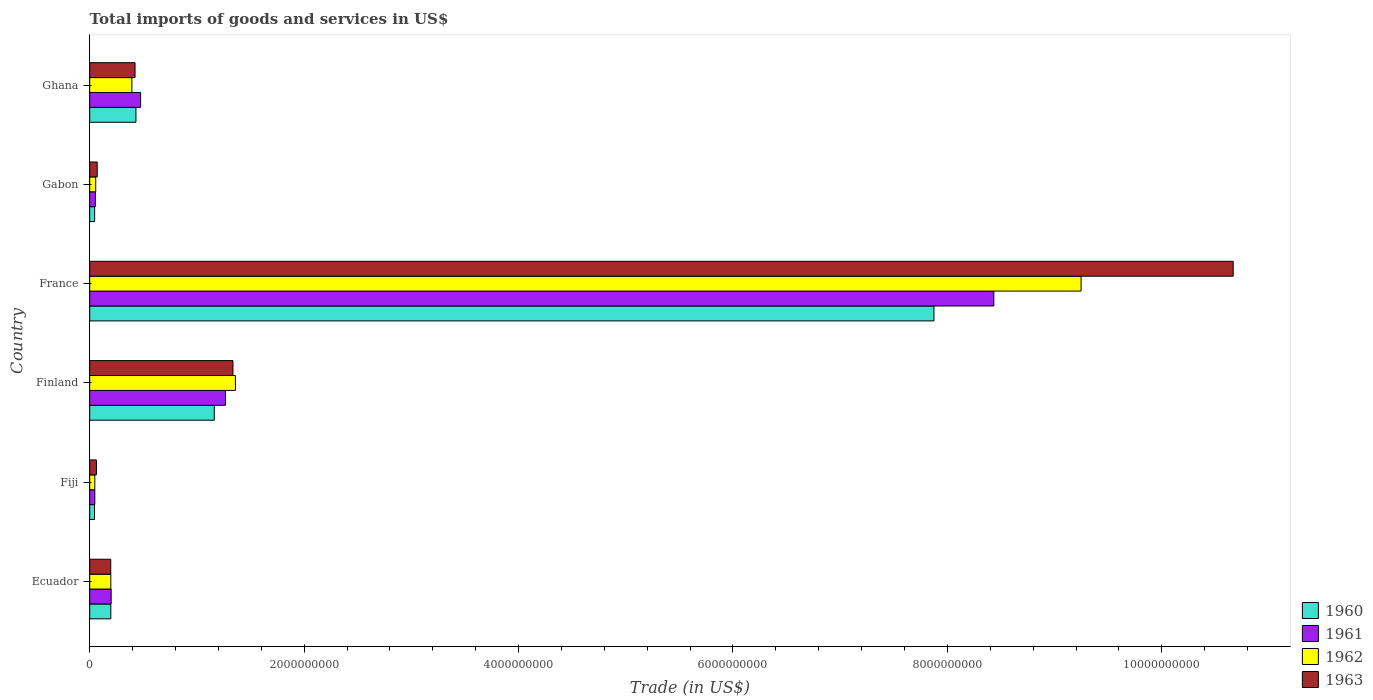How many different coloured bars are there?
Your answer should be compact. 4. Are the number of bars per tick equal to the number of legend labels?
Offer a very short reply. Yes. How many bars are there on the 5th tick from the top?
Keep it short and to the point. 4. What is the label of the 3rd group of bars from the top?
Offer a terse response. France. In how many cases, is the number of bars for a given country not equal to the number of legend labels?
Give a very brief answer. 0. What is the total imports of goods and services in 1960 in Ghana?
Provide a short and direct response. 4.31e+08. Across all countries, what is the maximum total imports of goods and services in 1962?
Your answer should be very brief. 9.25e+09. Across all countries, what is the minimum total imports of goods and services in 1961?
Your response must be concise. 4.77e+07. In which country was the total imports of goods and services in 1963 minimum?
Your answer should be very brief. Fiji. What is the total total imports of goods and services in 1963 in the graph?
Give a very brief answer. 1.28e+1. What is the difference between the total imports of goods and services in 1960 in Fiji and that in Ghana?
Make the answer very short. -3.87e+08. What is the difference between the total imports of goods and services in 1962 in Ghana and the total imports of goods and services in 1963 in Fiji?
Offer a terse response. 3.31e+08. What is the average total imports of goods and services in 1961 per country?
Your answer should be compact. 1.75e+09. What is the difference between the total imports of goods and services in 1960 and total imports of goods and services in 1962 in Ghana?
Your answer should be very brief. 3.78e+07. In how many countries, is the total imports of goods and services in 1962 greater than 3200000000 US$?
Ensure brevity in your answer.  1. What is the ratio of the total imports of goods and services in 1962 in Fiji to that in Gabon?
Offer a very short reply. 0.85. What is the difference between the highest and the second highest total imports of goods and services in 1963?
Make the answer very short. 9.33e+09. What is the difference between the highest and the lowest total imports of goods and services in 1962?
Give a very brief answer. 9.20e+09. In how many countries, is the total imports of goods and services in 1960 greater than the average total imports of goods and services in 1960 taken over all countries?
Provide a succinct answer. 1. Is it the case that in every country, the sum of the total imports of goods and services in 1963 and total imports of goods and services in 1960 is greater than the sum of total imports of goods and services in 1961 and total imports of goods and services in 1962?
Keep it short and to the point. No. What does the 4th bar from the bottom in Ecuador represents?
Your response must be concise. 1963. Is it the case that in every country, the sum of the total imports of goods and services in 1962 and total imports of goods and services in 1961 is greater than the total imports of goods and services in 1963?
Keep it short and to the point. Yes. How many bars are there?
Offer a terse response. 24. Are the values on the major ticks of X-axis written in scientific E-notation?
Keep it short and to the point. No. Does the graph contain any zero values?
Offer a very short reply. No. Where does the legend appear in the graph?
Provide a succinct answer. Bottom right. What is the title of the graph?
Your answer should be very brief. Total imports of goods and services in US$. What is the label or title of the X-axis?
Ensure brevity in your answer.  Trade (in US$). What is the label or title of the Y-axis?
Keep it short and to the point. Country. What is the Trade (in US$) of 1960 in Ecuador?
Make the answer very short. 1.97e+08. What is the Trade (in US$) in 1961 in Ecuador?
Offer a very short reply. 2.00e+08. What is the Trade (in US$) of 1962 in Ecuador?
Ensure brevity in your answer.  1.97e+08. What is the Trade (in US$) of 1963 in Ecuador?
Provide a succinct answer. 1.96e+08. What is the Trade (in US$) of 1960 in Fiji?
Offer a terse response. 4.48e+07. What is the Trade (in US$) of 1961 in Fiji?
Your answer should be very brief. 4.77e+07. What is the Trade (in US$) of 1962 in Fiji?
Your answer should be compact. 4.77e+07. What is the Trade (in US$) of 1963 in Fiji?
Keep it short and to the point. 6.30e+07. What is the Trade (in US$) of 1960 in Finland?
Your answer should be very brief. 1.16e+09. What is the Trade (in US$) of 1961 in Finland?
Offer a very short reply. 1.27e+09. What is the Trade (in US$) of 1962 in Finland?
Ensure brevity in your answer.  1.36e+09. What is the Trade (in US$) of 1963 in Finland?
Your answer should be very brief. 1.34e+09. What is the Trade (in US$) of 1960 in France?
Your response must be concise. 7.87e+09. What is the Trade (in US$) of 1961 in France?
Offer a very short reply. 8.43e+09. What is the Trade (in US$) in 1962 in France?
Your answer should be compact. 9.25e+09. What is the Trade (in US$) of 1963 in France?
Offer a terse response. 1.07e+1. What is the Trade (in US$) of 1960 in Gabon?
Offer a terse response. 4.62e+07. What is the Trade (in US$) in 1961 in Gabon?
Make the answer very short. 5.31e+07. What is the Trade (in US$) in 1962 in Gabon?
Keep it short and to the point. 5.62e+07. What is the Trade (in US$) in 1963 in Gabon?
Offer a very short reply. 7.01e+07. What is the Trade (in US$) of 1960 in Ghana?
Offer a very short reply. 4.31e+08. What is the Trade (in US$) in 1961 in Ghana?
Give a very brief answer. 4.75e+08. What is the Trade (in US$) in 1962 in Ghana?
Your response must be concise. 3.94e+08. What is the Trade (in US$) in 1963 in Ghana?
Make the answer very short. 4.23e+08. Across all countries, what is the maximum Trade (in US$) in 1960?
Give a very brief answer. 7.87e+09. Across all countries, what is the maximum Trade (in US$) of 1961?
Make the answer very short. 8.43e+09. Across all countries, what is the maximum Trade (in US$) of 1962?
Provide a short and direct response. 9.25e+09. Across all countries, what is the maximum Trade (in US$) in 1963?
Your answer should be very brief. 1.07e+1. Across all countries, what is the minimum Trade (in US$) of 1960?
Keep it short and to the point. 4.48e+07. Across all countries, what is the minimum Trade (in US$) in 1961?
Your response must be concise. 4.77e+07. Across all countries, what is the minimum Trade (in US$) in 1962?
Offer a very short reply. 4.77e+07. Across all countries, what is the minimum Trade (in US$) in 1963?
Give a very brief answer. 6.30e+07. What is the total Trade (in US$) of 1960 in the graph?
Offer a terse response. 9.76e+09. What is the total Trade (in US$) in 1961 in the graph?
Make the answer very short. 1.05e+1. What is the total Trade (in US$) in 1962 in the graph?
Your answer should be compact. 1.13e+1. What is the total Trade (in US$) of 1963 in the graph?
Give a very brief answer. 1.28e+1. What is the difference between the Trade (in US$) in 1960 in Ecuador and that in Fiji?
Your answer should be very brief. 1.52e+08. What is the difference between the Trade (in US$) in 1961 in Ecuador and that in Fiji?
Your answer should be compact. 1.53e+08. What is the difference between the Trade (in US$) of 1962 in Ecuador and that in Fiji?
Give a very brief answer. 1.49e+08. What is the difference between the Trade (in US$) of 1963 in Ecuador and that in Fiji?
Your response must be concise. 1.33e+08. What is the difference between the Trade (in US$) of 1960 in Ecuador and that in Finland?
Offer a very short reply. -9.65e+08. What is the difference between the Trade (in US$) in 1961 in Ecuador and that in Finland?
Keep it short and to the point. -1.07e+09. What is the difference between the Trade (in US$) in 1962 in Ecuador and that in Finland?
Your answer should be compact. -1.16e+09. What is the difference between the Trade (in US$) of 1963 in Ecuador and that in Finland?
Give a very brief answer. -1.14e+09. What is the difference between the Trade (in US$) in 1960 in Ecuador and that in France?
Your answer should be compact. -7.68e+09. What is the difference between the Trade (in US$) of 1961 in Ecuador and that in France?
Offer a terse response. -8.23e+09. What is the difference between the Trade (in US$) of 1962 in Ecuador and that in France?
Provide a succinct answer. -9.05e+09. What is the difference between the Trade (in US$) of 1963 in Ecuador and that in France?
Your answer should be very brief. -1.05e+1. What is the difference between the Trade (in US$) in 1960 in Ecuador and that in Gabon?
Your answer should be compact. 1.51e+08. What is the difference between the Trade (in US$) of 1961 in Ecuador and that in Gabon?
Your response must be concise. 1.47e+08. What is the difference between the Trade (in US$) in 1962 in Ecuador and that in Gabon?
Your response must be concise. 1.41e+08. What is the difference between the Trade (in US$) of 1963 in Ecuador and that in Gabon?
Ensure brevity in your answer.  1.26e+08. What is the difference between the Trade (in US$) in 1960 in Ecuador and that in Ghana?
Give a very brief answer. -2.35e+08. What is the difference between the Trade (in US$) of 1961 in Ecuador and that in Ghana?
Your answer should be very brief. -2.75e+08. What is the difference between the Trade (in US$) in 1962 in Ecuador and that in Ghana?
Keep it short and to the point. -1.97e+08. What is the difference between the Trade (in US$) in 1963 in Ecuador and that in Ghana?
Give a very brief answer. -2.27e+08. What is the difference between the Trade (in US$) of 1960 in Fiji and that in Finland?
Offer a terse response. -1.12e+09. What is the difference between the Trade (in US$) in 1961 in Fiji and that in Finland?
Offer a terse response. -1.22e+09. What is the difference between the Trade (in US$) in 1962 in Fiji and that in Finland?
Provide a short and direct response. -1.31e+09. What is the difference between the Trade (in US$) in 1963 in Fiji and that in Finland?
Ensure brevity in your answer.  -1.27e+09. What is the difference between the Trade (in US$) of 1960 in Fiji and that in France?
Make the answer very short. -7.83e+09. What is the difference between the Trade (in US$) of 1961 in Fiji and that in France?
Keep it short and to the point. -8.39e+09. What is the difference between the Trade (in US$) in 1962 in Fiji and that in France?
Provide a short and direct response. -9.20e+09. What is the difference between the Trade (in US$) of 1963 in Fiji and that in France?
Your response must be concise. -1.06e+1. What is the difference between the Trade (in US$) in 1960 in Fiji and that in Gabon?
Offer a very short reply. -1.32e+06. What is the difference between the Trade (in US$) in 1961 in Fiji and that in Gabon?
Keep it short and to the point. -5.35e+06. What is the difference between the Trade (in US$) in 1962 in Fiji and that in Gabon?
Make the answer very short. -8.51e+06. What is the difference between the Trade (in US$) of 1963 in Fiji and that in Gabon?
Your answer should be very brief. -7.16e+06. What is the difference between the Trade (in US$) in 1960 in Fiji and that in Ghana?
Provide a short and direct response. -3.87e+08. What is the difference between the Trade (in US$) in 1961 in Fiji and that in Ghana?
Provide a short and direct response. -4.27e+08. What is the difference between the Trade (in US$) in 1962 in Fiji and that in Ghana?
Your answer should be very brief. -3.46e+08. What is the difference between the Trade (in US$) of 1963 in Fiji and that in Ghana?
Ensure brevity in your answer.  -3.60e+08. What is the difference between the Trade (in US$) of 1960 in Finland and that in France?
Ensure brevity in your answer.  -6.71e+09. What is the difference between the Trade (in US$) in 1961 in Finland and that in France?
Provide a succinct answer. -7.17e+09. What is the difference between the Trade (in US$) of 1962 in Finland and that in France?
Make the answer very short. -7.89e+09. What is the difference between the Trade (in US$) of 1963 in Finland and that in France?
Offer a terse response. -9.33e+09. What is the difference between the Trade (in US$) of 1960 in Finland and that in Gabon?
Your answer should be very brief. 1.12e+09. What is the difference between the Trade (in US$) in 1961 in Finland and that in Gabon?
Make the answer very short. 1.21e+09. What is the difference between the Trade (in US$) in 1962 in Finland and that in Gabon?
Offer a terse response. 1.30e+09. What is the difference between the Trade (in US$) of 1963 in Finland and that in Gabon?
Make the answer very short. 1.27e+09. What is the difference between the Trade (in US$) in 1960 in Finland and that in Ghana?
Offer a very short reply. 7.30e+08. What is the difference between the Trade (in US$) of 1961 in Finland and that in Ghana?
Offer a terse response. 7.91e+08. What is the difference between the Trade (in US$) of 1962 in Finland and that in Ghana?
Keep it short and to the point. 9.66e+08. What is the difference between the Trade (in US$) of 1963 in Finland and that in Ghana?
Your response must be concise. 9.13e+08. What is the difference between the Trade (in US$) in 1960 in France and that in Gabon?
Ensure brevity in your answer.  7.83e+09. What is the difference between the Trade (in US$) in 1961 in France and that in Gabon?
Your answer should be very brief. 8.38e+09. What is the difference between the Trade (in US$) in 1962 in France and that in Gabon?
Provide a short and direct response. 9.19e+09. What is the difference between the Trade (in US$) of 1963 in France and that in Gabon?
Offer a very short reply. 1.06e+1. What is the difference between the Trade (in US$) of 1960 in France and that in Ghana?
Provide a succinct answer. 7.44e+09. What is the difference between the Trade (in US$) in 1961 in France and that in Ghana?
Ensure brevity in your answer.  7.96e+09. What is the difference between the Trade (in US$) in 1962 in France and that in Ghana?
Make the answer very short. 8.85e+09. What is the difference between the Trade (in US$) in 1963 in France and that in Ghana?
Your answer should be compact. 1.02e+1. What is the difference between the Trade (in US$) of 1960 in Gabon and that in Ghana?
Provide a short and direct response. -3.85e+08. What is the difference between the Trade (in US$) in 1961 in Gabon and that in Ghana?
Make the answer very short. -4.22e+08. What is the difference between the Trade (in US$) of 1962 in Gabon and that in Ghana?
Your answer should be compact. -3.37e+08. What is the difference between the Trade (in US$) in 1963 in Gabon and that in Ghana?
Provide a succinct answer. -3.53e+08. What is the difference between the Trade (in US$) in 1960 in Ecuador and the Trade (in US$) in 1961 in Fiji?
Make the answer very short. 1.49e+08. What is the difference between the Trade (in US$) of 1960 in Ecuador and the Trade (in US$) of 1962 in Fiji?
Your response must be concise. 1.49e+08. What is the difference between the Trade (in US$) in 1960 in Ecuador and the Trade (in US$) in 1963 in Fiji?
Your response must be concise. 1.34e+08. What is the difference between the Trade (in US$) of 1961 in Ecuador and the Trade (in US$) of 1962 in Fiji?
Keep it short and to the point. 1.53e+08. What is the difference between the Trade (in US$) of 1961 in Ecuador and the Trade (in US$) of 1963 in Fiji?
Offer a very short reply. 1.37e+08. What is the difference between the Trade (in US$) of 1962 in Ecuador and the Trade (in US$) of 1963 in Fiji?
Make the answer very short. 1.34e+08. What is the difference between the Trade (in US$) of 1960 in Ecuador and the Trade (in US$) of 1961 in Finland?
Offer a terse response. -1.07e+09. What is the difference between the Trade (in US$) in 1960 in Ecuador and the Trade (in US$) in 1962 in Finland?
Give a very brief answer. -1.16e+09. What is the difference between the Trade (in US$) of 1960 in Ecuador and the Trade (in US$) of 1963 in Finland?
Your answer should be compact. -1.14e+09. What is the difference between the Trade (in US$) in 1961 in Ecuador and the Trade (in US$) in 1962 in Finland?
Offer a terse response. -1.16e+09. What is the difference between the Trade (in US$) of 1961 in Ecuador and the Trade (in US$) of 1963 in Finland?
Your response must be concise. -1.14e+09. What is the difference between the Trade (in US$) of 1962 in Ecuador and the Trade (in US$) of 1963 in Finland?
Give a very brief answer. -1.14e+09. What is the difference between the Trade (in US$) in 1960 in Ecuador and the Trade (in US$) in 1961 in France?
Make the answer very short. -8.24e+09. What is the difference between the Trade (in US$) of 1960 in Ecuador and the Trade (in US$) of 1962 in France?
Your response must be concise. -9.05e+09. What is the difference between the Trade (in US$) of 1960 in Ecuador and the Trade (in US$) of 1963 in France?
Offer a terse response. -1.05e+1. What is the difference between the Trade (in US$) in 1961 in Ecuador and the Trade (in US$) in 1962 in France?
Offer a very short reply. -9.05e+09. What is the difference between the Trade (in US$) in 1961 in Ecuador and the Trade (in US$) in 1963 in France?
Your response must be concise. -1.05e+1. What is the difference between the Trade (in US$) in 1962 in Ecuador and the Trade (in US$) in 1963 in France?
Ensure brevity in your answer.  -1.05e+1. What is the difference between the Trade (in US$) in 1960 in Ecuador and the Trade (in US$) in 1961 in Gabon?
Offer a very short reply. 1.44e+08. What is the difference between the Trade (in US$) of 1960 in Ecuador and the Trade (in US$) of 1962 in Gabon?
Give a very brief answer. 1.41e+08. What is the difference between the Trade (in US$) of 1960 in Ecuador and the Trade (in US$) of 1963 in Gabon?
Your answer should be very brief. 1.27e+08. What is the difference between the Trade (in US$) in 1961 in Ecuador and the Trade (in US$) in 1962 in Gabon?
Provide a short and direct response. 1.44e+08. What is the difference between the Trade (in US$) in 1961 in Ecuador and the Trade (in US$) in 1963 in Gabon?
Your answer should be compact. 1.30e+08. What is the difference between the Trade (in US$) in 1962 in Ecuador and the Trade (in US$) in 1963 in Gabon?
Offer a terse response. 1.27e+08. What is the difference between the Trade (in US$) of 1960 in Ecuador and the Trade (in US$) of 1961 in Ghana?
Provide a short and direct response. -2.78e+08. What is the difference between the Trade (in US$) in 1960 in Ecuador and the Trade (in US$) in 1962 in Ghana?
Provide a succinct answer. -1.97e+08. What is the difference between the Trade (in US$) of 1960 in Ecuador and the Trade (in US$) of 1963 in Ghana?
Keep it short and to the point. -2.26e+08. What is the difference between the Trade (in US$) in 1961 in Ecuador and the Trade (in US$) in 1962 in Ghana?
Your answer should be compact. -1.93e+08. What is the difference between the Trade (in US$) of 1961 in Ecuador and the Trade (in US$) of 1963 in Ghana?
Provide a succinct answer. -2.23e+08. What is the difference between the Trade (in US$) in 1962 in Ecuador and the Trade (in US$) in 1963 in Ghana?
Offer a terse response. -2.26e+08. What is the difference between the Trade (in US$) in 1960 in Fiji and the Trade (in US$) in 1961 in Finland?
Give a very brief answer. -1.22e+09. What is the difference between the Trade (in US$) in 1960 in Fiji and the Trade (in US$) in 1962 in Finland?
Your answer should be compact. -1.31e+09. What is the difference between the Trade (in US$) of 1960 in Fiji and the Trade (in US$) of 1963 in Finland?
Your response must be concise. -1.29e+09. What is the difference between the Trade (in US$) of 1961 in Fiji and the Trade (in US$) of 1962 in Finland?
Give a very brief answer. -1.31e+09. What is the difference between the Trade (in US$) of 1961 in Fiji and the Trade (in US$) of 1963 in Finland?
Ensure brevity in your answer.  -1.29e+09. What is the difference between the Trade (in US$) in 1962 in Fiji and the Trade (in US$) in 1963 in Finland?
Provide a succinct answer. -1.29e+09. What is the difference between the Trade (in US$) of 1960 in Fiji and the Trade (in US$) of 1961 in France?
Your answer should be very brief. -8.39e+09. What is the difference between the Trade (in US$) of 1960 in Fiji and the Trade (in US$) of 1962 in France?
Provide a short and direct response. -9.20e+09. What is the difference between the Trade (in US$) of 1960 in Fiji and the Trade (in US$) of 1963 in France?
Make the answer very short. -1.06e+1. What is the difference between the Trade (in US$) in 1961 in Fiji and the Trade (in US$) in 1962 in France?
Provide a succinct answer. -9.20e+09. What is the difference between the Trade (in US$) in 1961 in Fiji and the Trade (in US$) in 1963 in France?
Ensure brevity in your answer.  -1.06e+1. What is the difference between the Trade (in US$) of 1962 in Fiji and the Trade (in US$) of 1963 in France?
Provide a succinct answer. -1.06e+1. What is the difference between the Trade (in US$) in 1960 in Fiji and the Trade (in US$) in 1961 in Gabon?
Your response must be concise. -8.25e+06. What is the difference between the Trade (in US$) in 1960 in Fiji and the Trade (in US$) in 1962 in Gabon?
Give a very brief answer. -1.14e+07. What is the difference between the Trade (in US$) in 1960 in Fiji and the Trade (in US$) in 1963 in Gabon?
Give a very brief answer. -2.53e+07. What is the difference between the Trade (in US$) in 1961 in Fiji and the Trade (in US$) in 1962 in Gabon?
Ensure brevity in your answer.  -8.51e+06. What is the difference between the Trade (in US$) in 1961 in Fiji and the Trade (in US$) in 1963 in Gabon?
Make the answer very short. -2.24e+07. What is the difference between the Trade (in US$) in 1962 in Fiji and the Trade (in US$) in 1963 in Gabon?
Your response must be concise. -2.24e+07. What is the difference between the Trade (in US$) of 1960 in Fiji and the Trade (in US$) of 1961 in Ghana?
Your response must be concise. -4.30e+08. What is the difference between the Trade (in US$) of 1960 in Fiji and the Trade (in US$) of 1962 in Ghana?
Give a very brief answer. -3.49e+08. What is the difference between the Trade (in US$) in 1960 in Fiji and the Trade (in US$) in 1963 in Ghana?
Make the answer very short. -3.78e+08. What is the difference between the Trade (in US$) in 1961 in Fiji and the Trade (in US$) in 1962 in Ghana?
Offer a very short reply. -3.46e+08. What is the difference between the Trade (in US$) of 1961 in Fiji and the Trade (in US$) of 1963 in Ghana?
Give a very brief answer. -3.75e+08. What is the difference between the Trade (in US$) in 1962 in Fiji and the Trade (in US$) in 1963 in Ghana?
Make the answer very short. -3.75e+08. What is the difference between the Trade (in US$) of 1960 in Finland and the Trade (in US$) of 1961 in France?
Provide a short and direct response. -7.27e+09. What is the difference between the Trade (in US$) of 1960 in Finland and the Trade (in US$) of 1962 in France?
Ensure brevity in your answer.  -8.08e+09. What is the difference between the Trade (in US$) of 1960 in Finland and the Trade (in US$) of 1963 in France?
Make the answer very short. -9.50e+09. What is the difference between the Trade (in US$) of 1961 in Finland and the Trade (in US$) of 1962 in France?
Your response must be concise. -7.98e+09. What is the difference between the Trade (in US$) of 1961 in Finland and the Trade (in US$) of 1963 in France?
Your response must be concise. -9.40e+09. What is the difference between the Trade (in US$) in 1962 in Finland and the Trade (in US$) in 1963 in France?
Ensure brevity in your answer.  -9.31e+09. What is the difference between the Trade (in US$) in 1960 in Finland and the Trade (in US$) in 1961 in Gabon?
Offer a terse response. 1.11e+09. What is the difference between the Trade (in US$) of 1960 in Finland and the Trade (in US$) of 1962 in Gabon?
Offer a terse response. 1.11e+09. What is the difference between the Trade (in US$) in 1960 in Finland and the Trade (in US$) in 1963 in Gabon?
Your answer should be very brief. 1.09e+09. What is the difference between the Trade (in US$) of 1961 in Finland and the Trade (in US$) of 1962 in Gabon?
Offer a very short reply. 1.21e+09. What is the difference between the Trade (in US$) of 1961 in Finland and the Trade (in US$) of 1963 in Gabon?
Make the answer very short. 1.20e+09. What is the difference between the Trade (in US$) in 1962 in Finland and the Trade (in US$) in 1963 in Gabon?
Your response must be concise. 1.29e+09. What is the difference between the Trade (in US$) in 1960 in Finland and the Trade (in US$) in 1961 in Ghana?
Offer a terse response. 6.87e+08. What is the difference between the Trade (in US$) in 1960 in Finland and the Trade (in US$) in 1962 in Ghana?
Offer a terse response. 7.68e+08. What is the difference between the Trade (in US$) in 1960 in Finland and the Trade (in US$) in 1963 in Ghana?
Provide a short and direct response. 7.39e+08. What is the difference between the Trade (in US$) of 1961 in Finland and the Trade (in US$) of 1962 in Ghana?
Offer a very short reply. 8.73e+08. What is the difference between the Trade (in US$) of 1961 in Finland and the Trade (in US$) of 1963 in Ghana?
Offer a terse response. 8.43e+08. What is the difference between the Trade (in US$) of 1962 in Finland and the Trade (in US$) of 1963 in Ghana?
Ensure brevity in your answer.  9.36e+08. What is the difference between the Trade (in US$) in 1960 in France and the Trade (in US$) in 1961 in Gabon?
Your response must be concise. 7.82e+09. What is the difference between the Trade (in US$) of 1960 in France and the Trade (in US$) of 1962 in Gabon?
Ensure brevity in your answer.  7.82e+09. What is the difference between the Trade (in US$) of 1960 in France and the Trade (in US$) of 1963 in Gabon?
Your response must be concise. 7.80e+09. What is the difference between the Trade (in US$) of 1961 in France and the Trade (in US$) of 1962 in Gabon?
Keep it short and to the point. 8.38e+09. What is the difference between the Trade (in US$) in 1961 in France and the Trade (in US$) in 1963 in Gabon?
Make the answer very short. 8.36e+09. What is the difference between the Trade (in US$) in 1962 in France and the Trade (in US$) in 1963 in Gabon?
Your answer should be very brief. 9.18e+09. What is the difference between the Trade (in US$) of 1960 in France and the Trade (in US$) of 1961 in Ghana?
Provide a short and direct response. 7.40e+09. What is the difference between the Trade (in US$) in 1960 in France and the Trade (in US$) in 1962 in Ghana?
Keep it short and to the point. 7.48e+09. What is the difference between the Trade (in US$) of 1960 in France and the Trade (in US$) of 1963 in Ghana?
Ensure brevity in your answer.  7.45e+09. What is the difference between the Trade (in US$) in 1961 in France and the Trade (in US$) in 1962 in Ghana?
Provide a short and direct response. 8.04e+09. What is the difference between the Trade (in US$) of 1961 in France and the Trade (in US$) of 1963 in Ghana?
Your answer should be very brief. 8.01e+09. What is the difference between the Trade (in US$) in 1962 in France and the Trade (in US$) in 1963 in Ghana?
Keep it short and to the point. 8.82e+09. What is the difference between the Trade (in US$) in 1960 in Gabon and the Trade (in US$) in 1961 in Ghana?
Offer a very short reply. -4.29e+08. What is the difference between the Trade (in US$) in 1960 in Gabon and the Trade (in US$) in 1962 in Ghana?
Give a very brief answer. -3.47e+08. What is the difference between the Trade (in US$) of 1960 in Gabon and the Trade (in US$) of 1963 in Ghana?
Make the answer very short. -3.77e+08. What is the difference between the Trade (in US$) of 1961 in Gabon and the Trade (in US$) of 1962 in Ghana?
Your response must be concise. -3.41e+08. What is the difference between the Trade (in US$) in 1961 in Gabon and the Trade (in US$) in 1963 in Ghana?
Your answer should be compact. -3.70e+08. What is the difference between the Trade (in US$) in 1962 in Gabon and the Trade (in US$) in 1963 in Ghana?
Offer a terse response. -3.67e+08. What is the average Trade (in US$) in 1960 per country?
Offer a terse response. 1.63e+09. What is the average Trade (in US$) in 1961 per country?
Offer a terse response. 1.75e+09. What is the average Trade (in US$) of 1962 per country?
Provide a succinct answer. 1.88e+09. What is the average Trade (in US$) in 1963 per country?
Ensure brevity in your answer.  2.13e+09. What is the difference between the Trade (in US$) of 1960 and Trade (in US$) of 1961 in Ecuador?
Keep it short and to the point. -3.37e+06. What is the difference between the Trade (in US$) of 1960 and Trade (in US$) of 1962 in Ecuador?
Provide a short and direct response. -1.34e+05. What is the difference between the Trade (in US$) of 1960 and Trade (in US$) of 1963 in Ecuador?
Your answer should be very brief. 5.38e+05. What is the difference between the Trade (in US$) in 1961 and Trade (in US$) in 1962 in Ecuador?
Give a very brief answer. 3.24e+06. What is the difference between the Trade (in US$) in 1961 and Trade (in US$) in 1963 in Ecuador?
Your response must be concise. 3.91e+06. What is the difference between the Trade (in US$) of 1962 and Trade (in US$) of 1963 in Ecuador?
Provide a short and direct response. 6.72e+05. What is the difference between the Trade (in US$) in 1960 and Trade (in US$) in 1961 in Fiji?
Provide a succinct answer. -2.90e+06. What is the difference between the Trade (in US$) in 1960 and Trade (in US$) in 1962 in Fiji?
Make the answer very short. -2.90e+06. What is the difference between the Trade (in US$) of 1960 and Trade (in US$) of 1963 in Fiji?
Make the answer very short. -1.81e+07. What is the difference between the Trade (in US$) of 1961 and Trade (in US$) of 1963 in Fiji?
Your response must be concise. -1.52e+07. What is the difference between the Trade (in US$) of 1962 and Trade (in US$) of 1963 in Fiji?
Offer a terse response. -1.52e+07. What is the difference between the Trade (in US$) of 1960 and Trade (in US$) of 1961 in Finland?
Your answer should be very brief. -1.04e+08. What is the difference between the Trade (in US$) of 1960 and Trade (in US$) of 1962 in Finland?
Ensure brevity in your answer.  -1.97e+08. What is the difference between the Trade (in US$) in 1960 and Trade (in US$) in 1963 in Finland?
Your answer should be very brief. -1.75e+08. What is the difference between the Trade (in US$) in 1961 and Trade (in US$) in 1962 in Finland?
Give a very brief answer. -9.31e+07. What is the difference between the Trade (in US$) of 1961 and Trade (in US$) of 1963 in Finland?
Provide a short and direct response. -7.02e+07. What is the difference between the Trade (in US$) of 1962 and Trade (in US$) of 1963 in Finland?
Offer a terse response. 2.29e+07. What is the difference between the Trade (in US$) in 1960 and Trade (in US$) in 1961 in France?
Make the answer very short. -5.58e+08. What is the difference between the Trade (in US$) in 1960 and Trade (in US$) in 1962 in France?
Ensure brevity in your answer.  -1.37e+09. What is the difference between the Trade (in US$) in 1960 and Trade (in US$) in 1963 in France?
Your answer should be very brief. -2.79e+09. What is the difference between the Trade (in US$) of 1961 and Trade (in US$) of 1962 in France?
Give a very brief answer. -8.14e+08. What is the difference between the Trade (in US$) of 1961 and Trade (in US$) of 1963 in France?
Offer a very short reply. -2.23e+09. What is the difference between the Trade (in US$) in 1962 and Trade (in US$) in 1963 in France?
Offer a very short reply. -1.42e+09. What is the difference between the Trade (in US$) of 1960 and Trade (in US$) of 1961 in Gabon?
Make the answer very short. -6.92e+06. What is the difference between the Trade (in US$) in 1960 and Trade (in US$) in 1962 in Gabon?
Ensure brevity in your answer.  -1.01e+07. What is the difference between the Trade (in US$) in 1960 and Trade (in US$) in 1963 in Gabon?
Make the answer very short. -2.40e+07. What is the difference between the Trade (in US$) of 1961 and Trade (in US$) of 1962 in Gabon?
Provide a succinct answer. -3.16e+06. What is the difference between the Trade (in US$) in 1961 and Trade (in US$) in 1963 in Gabon?
Your answer should be very brief. -1.70e+07. What is the difference between the Trade (in US$) in 1962 and Trade (in US$) in 1963 in Gabon?
Keep it short and to the point. -1.39e+07. What is the difference between the Trade (in US$) in 1960 and Trade (in US$) in 1961 in Ghana?
Give a very brief answer. -4.34e+07. What is the difference between the Trade (in US$) in 1960 and Trade (in US$) in 1962 in Ghana?
Offer a terse response. 3.78e+07. What is the difference between the Trade (in US$) in 1960 and Trade (in US$) in 1963 in Ghana?
Your answer should be compact. 8.40e+06. What is the difference between the Trade (in US$) of 1961 and Trade (in US$) of 1962 in Ghana?
Your answer should be compact. 8.12e+07. What is the difference between the Trade (in US$) of 1961 and Trade (in US$) of 1963 in Ghana?
Give a very brief answer. 5.18e+07. What is the difference between the Trade (in US$) of 1962 and Trade (in US$) of 1963 in Ghana?
Keep it short and to the point. -2.94e+07. What is the ratio of the Trade (in US$) of 1960 in Ecuador to that in Fiji?
Provide a short and direct response. 4.39. What is the ratio of the Trade (in US$) in 1961 in Ecuador to that in Fiji?
Your response must be concise. 4.2. What is the ratio of the Trade (in US$) of 1962 in Ecuador to that in Fiji?
Offer a very short reply. 4.13. What is the ratio of the Trade (in US$) in 1963 in Ecuador to that in Fiji?
Your answer should be very brief. 3.12. What is the ratio of the Trade (in US$) in 1960 in Ecuador to that in Finland?
Offer a very short reply. 0.17. What is the ratio of the Trade (in US$) in 1961 in Ecuador to that in Finland?
Offer a very short reply. 0.16. What is the ratio of the Trade (in US$) of 1962 in Ecuador to that in Finland?
Provide a short and direct response. 0.14. What is the ratio of the Trade (in US$) of 1963 in Ecuador to that in Finland?
Your answer should be compact. 0.15. What is the ratio of the Trade (in US$) in 1960 in Ecuador to that in France?
Provide a succinct answer. 0.03. What is the ratio of the Trade (in US$) in 1961 in Ecuador to that in France?
Give a very brief answer. 0.02. What is the ratio of the Trade (in US$) of 1962 in Ecuador to that in France?
Offer a very short reply. 0.02. What is the ratio of the Trade (in US$) in 1963 in Ecuador to that in France?
Your response must be concise. 0.02. What is the ratio of the Trade (in US$) in 1960 in Ecuador to that in Gabon?
Provide a short and direct response. 4.27. What is the ratio of the Trade (in US$) of 1961 in Ecuador to that in Gabon?
Offer a very short reply. 3.77. What is the ratio of the Trade (in US$) of 1962 in Ecuador to that in Gabon?
Your response must be concise. 3.5. What is the ratio of the Trade (in US$) in 1963 in Ecuador to that in Gabon?
Provide a succinct answer. 2.8. What is the ratio of the Trade (in US$) in 1960 in Ecuador to that in Ghana?
Provide a succinct answer. 0.46. What is the ratio of the Trade (in US$) of 1961 in Ecuador to that in Ghana?
Offer a terse response. 0.42. What is the ratio of the Trade (in US$) in 1962 in Ecuador to that in Ghana?
Your answer should be compact. 0.5. What is the ratio of the Trade (in US$) in 1963 in Ecuador to that in Ghana?
Ensure brevity in your answer.  0.46. What is the ratio of the Trade (in US$) of 1960 in Fiji to that in Finland?
Your answer should be very brief. 0.04. What is the ratio of the Trade (in US$) in 1961 in Fiji to that in Finland?
Keep it short and to the point. 0.04. What is the ratio of the Trade (in US$) in 1962 in Fiji to that in Finland?
Make the answer very short. 0.04. What is the ratio of the Trade (in US$) of 1963 in Fiji to that in Finland?
Make the answer very short. 0.05. What is the ratio of the Trade (in US$) of 1960 in Fiji to that in France?
Provide a succinct answer. 0.01. What is the ratio of the Trade (in US$) in 1961 in Fiji to that in France?
Give a very brief answer. 0.01. What is the ratio of the Trade (in US$) of 1962 in Fiji to that in France?
Give a very brief answer. 0.01. What is the ratio of the Trade (in US$) in 1963 in Fiji to that in France?
Provide a short and direct response. 0.01. What is the ratio of the Trade (in US$) in 1960 in Fiji to that in Gabon?
Your response must be concise. 0.97. What is the ratio of the Trade (in US$) of 1961 in Fiji to that in Gabon?
Your answer should be compact. 0.9. What is the ratio of the Trade (in US$) in 1962 in Fiji to that in Gabon?
Offer a very short reply. 0.85. What is the ratio of the Trade (in US$) in 1963 in Fiji to that in Gabon?
Offer a very short reply. 0.9. What is the ratio of the Trade (in US$) of 1960 in Fiji to that in Ghana?
Your answer should be very brief. 0.1. What is the ratio of the Trade (in US$) in 1961 in Fiji to that in Ghana?
Provide a short and direct response. 0.1. What is the ratio of the Trade (in US$) of 1962 in Fiji to that in Ghana?
Your answer should be compact. 0.12. What is the ratio of the Trade (in US$) of 1963 in Fiji to that in Ghana?
Provide a short and direct response. 0.15. What is the ratio of the Trade (in US$) in 1960 in Finland to that in France?
Keep it short and to the point. 0.15. What is the ratio of the Trade (in US$) of 1961 in Finland to that in France?
Make the answer very short. 0.15. What is the ratio of the Trade (in US$) of 1962 in Finland to that in France?
Keep it short and to the point. 0.15. What is the ratio of the Trade (in US$) of 1963 in Finland to that in France?
Give a very brief answer. 0.13. What is the ratio of the Trade (in US$) in 1960 in Finland to that in Gabon?
Offer a very short reply. 25.17. What is the ratio of the Trade (in US$) in 1961 in Finland to that in Gabon?
Offer a terse response. 23.85. What is the ratio of the Trade (in US$) of 1962 in Finland to that in Gabon?
Your answer should be compact. 24.17. What is the ratio of the Trade (in US$) of 1963 in Finland to that in Gabon?
Ensure brevity in your answer.  19.06. What is the ratio of the Trade (in US$) in 1960 in Finland to that in Ghana?
Your answer should be compact. 2.69. What is the ratio of the Trade (in US$) in 1961 in Finland to that in Ghana?
Your answer should be compact. 2.67. What is the ratio of the Trade (in US$) of 1962 in Finland to that in Ghana?
Your response must be concise. 3.45. What is the ratio of the Trade (in US$) of 1963 in Finland to that in Ghana?
Give a very brief answer. 3.16. What is the ratio of the Trade (in US$) in 1960 in France to that in Gabon?
Offer a terse response. 170.61. What is the ratio of the Trade (in US$) of 1961 in France to that in Gabon?
Offer a very short reply. 158.88. What is the ratio of the Trade (in US$) of 1962 in France to that in Gabon?
Ensure brevity in your answer.  164.41. What is the ratio of the Trade (in US$) of 1963 in France to that in Gabon?
Ensure brevity in your answer.  152.1. What is the ratio of the Trade (in US$) in 1960 in France to that in Ghana?
Your response must be concise. 18.25. What is the ratio of the Trade (in US$) in 1961 in France to that in Ghana?
Your answer should be very brief. 17.76. What is the ratio of the Trade (in US$) of 1962 in France to that in Ghana?
Make the answer very short. 23.49. What is the ratio of the Trade (in US$) of 1963 in France to that in Ghana?
Offer a very short reply. 25.21. What is the ratio of the Trade (in US$) in 1960 in Gabon to that in Ghana?
Your answer should be very brief. 0.11. What is the ratio of the Trade (in US$) in 1961 in Gabon to that in Ghana?
Keep it short and to the point. 0.11. What is the ratio of the Trade (in US$) in 1962 in Gabon to that in Ghana?
Give a very brief answer. 0.14. What is the ratio of the Trade (in US$) in 1963 in Gabon to that in Ghana?
Provide a succinct answer. 0.17. What is the difference between the highest and the second highest Trade (in US$) of 1960?
Provide a succinct answer. 6.71e+09. What is the difference between the highest and the second highest Trade (in US$) of 1961?
Your answer should be very brief. 7.17e+09. What is the difference between the highest and the second highest Trade (in US$) in 1962?
Offer a terse response. 7.89e+09. What is the difference between the highest and the second highest Trade (in US$) in 1963?
Give a very brief answer. 9.33e+09. What is the difference between the highest and the lowest Trade (in US$) in 1960?
Give a very brief answer. 7.83e+09. What is the difference between the highest and the lowest Trade (in US$) of 1961?
Offer a very short reply. 8.39e+09. What is the difference between the highest and the lowest Trade (in US$) of 1962?
Offer a very short reply. 9.20e+09. What is the difference between the highest and the lowest Trade (in US$) of 1963?
Give a very brief answer. 1.06e+1. 